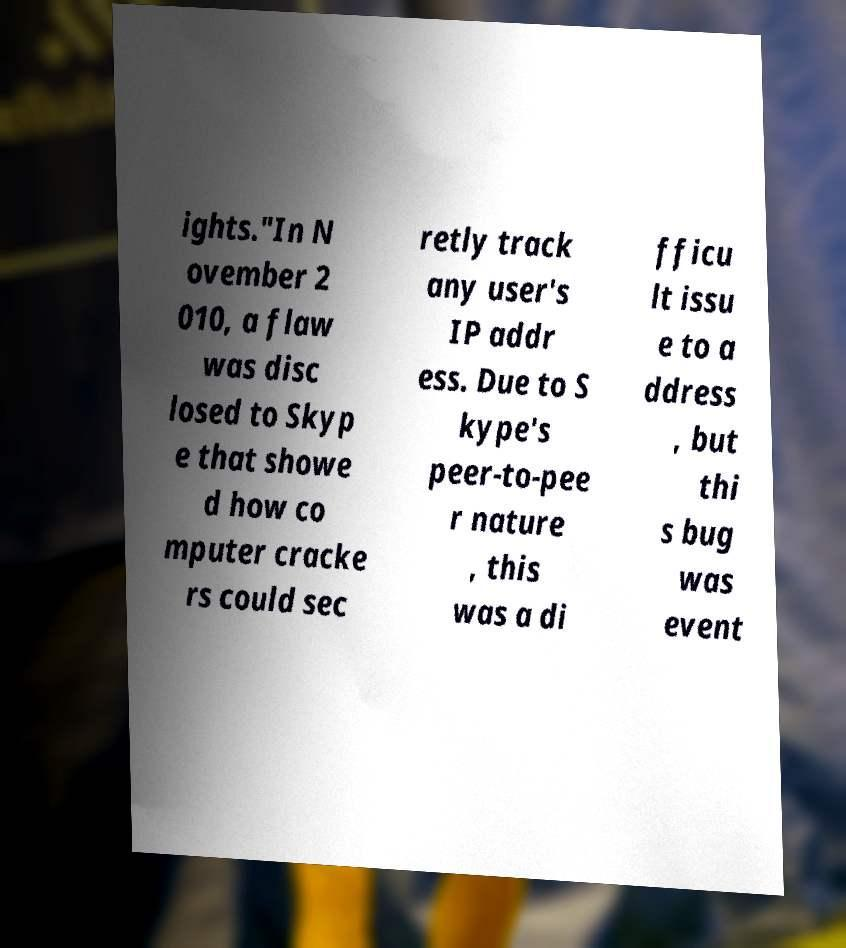Please identify and transcribe the text found in this image. ights."In N ovember 2 010, a flaw was disc losed to Skyp e that showe d how co mputer cracke rs could sec retly track any user's IP addr ess. Due to S kype's peer-to-pee r nature , this was a di fficu lt issu e to a ddress , but thi s bug was event 